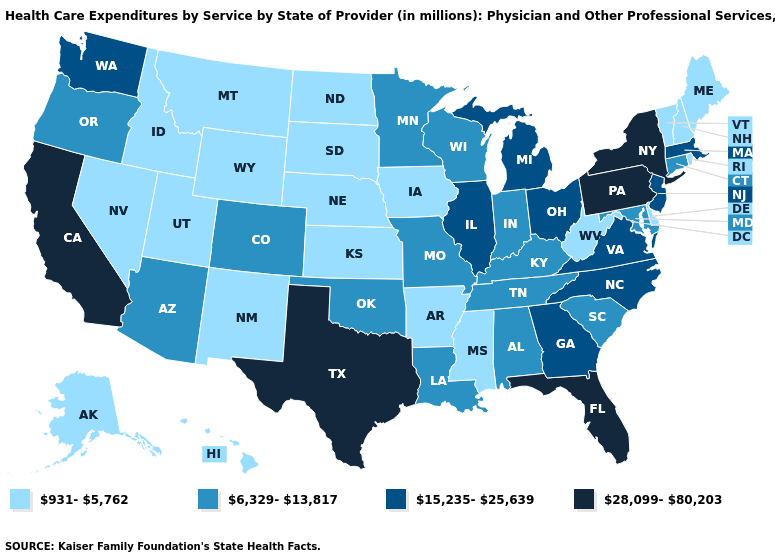Does Florida have the highest value in the South?
Be succinct. Yes. What is the value of Oklahoma?
Write a very short answer. 6,329-13,817. Does the map have missing data?
Quick response, please. No. Does Nevada have the lowest value in the USA?
Short answer required. Yes. What is the lowest value in states that border Kentucky?
Write a very short answer. 931-5,762. Name the states that have a value in the range 6,329-13,817?
Be succinct. Alabama, Arizona, Colorado, Connecticut, Indiana, Kentucky, Louisiana, Maryland, Minnesota, Missouri, Oklahoma, Oregon, South Carolina, Tennessee, Wisconsin. Does New York have the highest value in the USA?
Keep it brief. Yes. Among the states that border Texas , does New Mexico have the highest value?
Answer briefly. No. Name the states that have a value in the range 28,099-80,203?
Short answer required. California, Florida, New York, Pennsylvania, Texas. Which states hav the highest value in the Northeast?
Quick response, please. New York, Pennsylvania. Name the states that have a value in the range 931-5,762?
Be succinct. Alaska, Arkansas, Delaware, Hawaii, Idaho, Iowa, Kansas, Maine, Mississippi, Montana, Nebraska, Nevada, New Hampshire, New Mexico, North Dakota, Rhode Island, South Dakota, Utah, Vermont, West Virginia, Wyoming. Does Virginia have a lower value than California?
Keep it brief. Yes. Is the legend a continuous bar?
Give a very brief answer. No. What is the value of Ohio?
Concise answer only. 15,235-25,639. Does Virginia have the same value as North Dakota?
Keep it brief. No. 